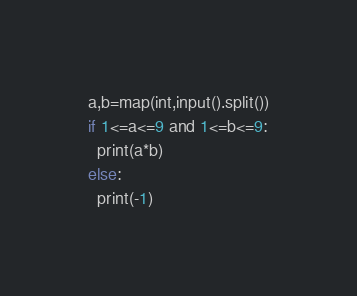<code> <loc_0><loc_0><loc_500><loc_500><_Python_>a,b=map(int,input().split())
if 1<=a<=9 and 1<=b<=9:
  print(a*b)
else:
  print(-1)</code> 